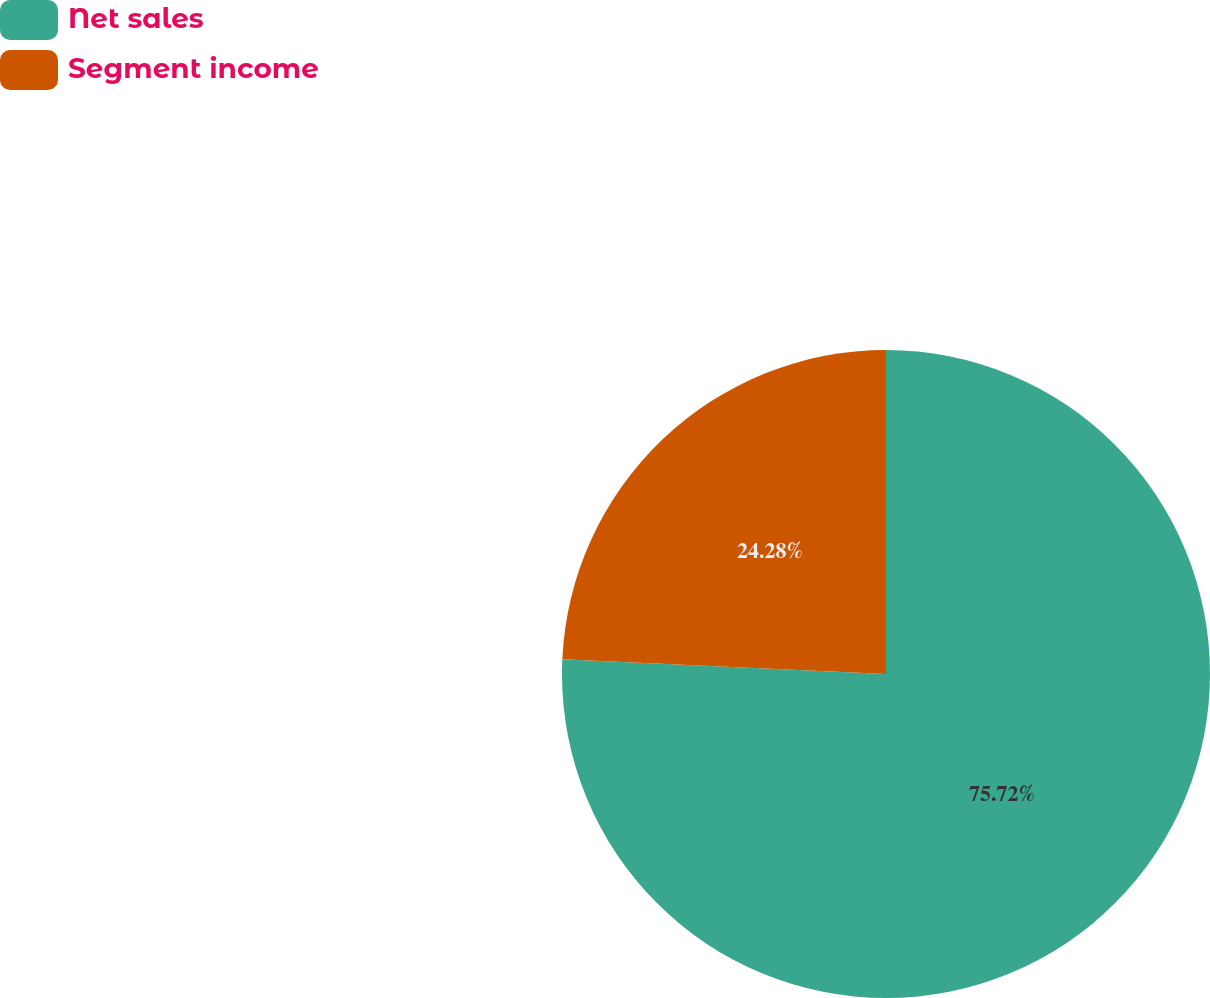Convert chart to OTSL. <chart><loc_0><loc_0><loc_500><loc_500><pie_chart><fcel>Net sales<fcel>Segment income<nl><fcel>75.72%<fcel>24.28%<nl></chart> 